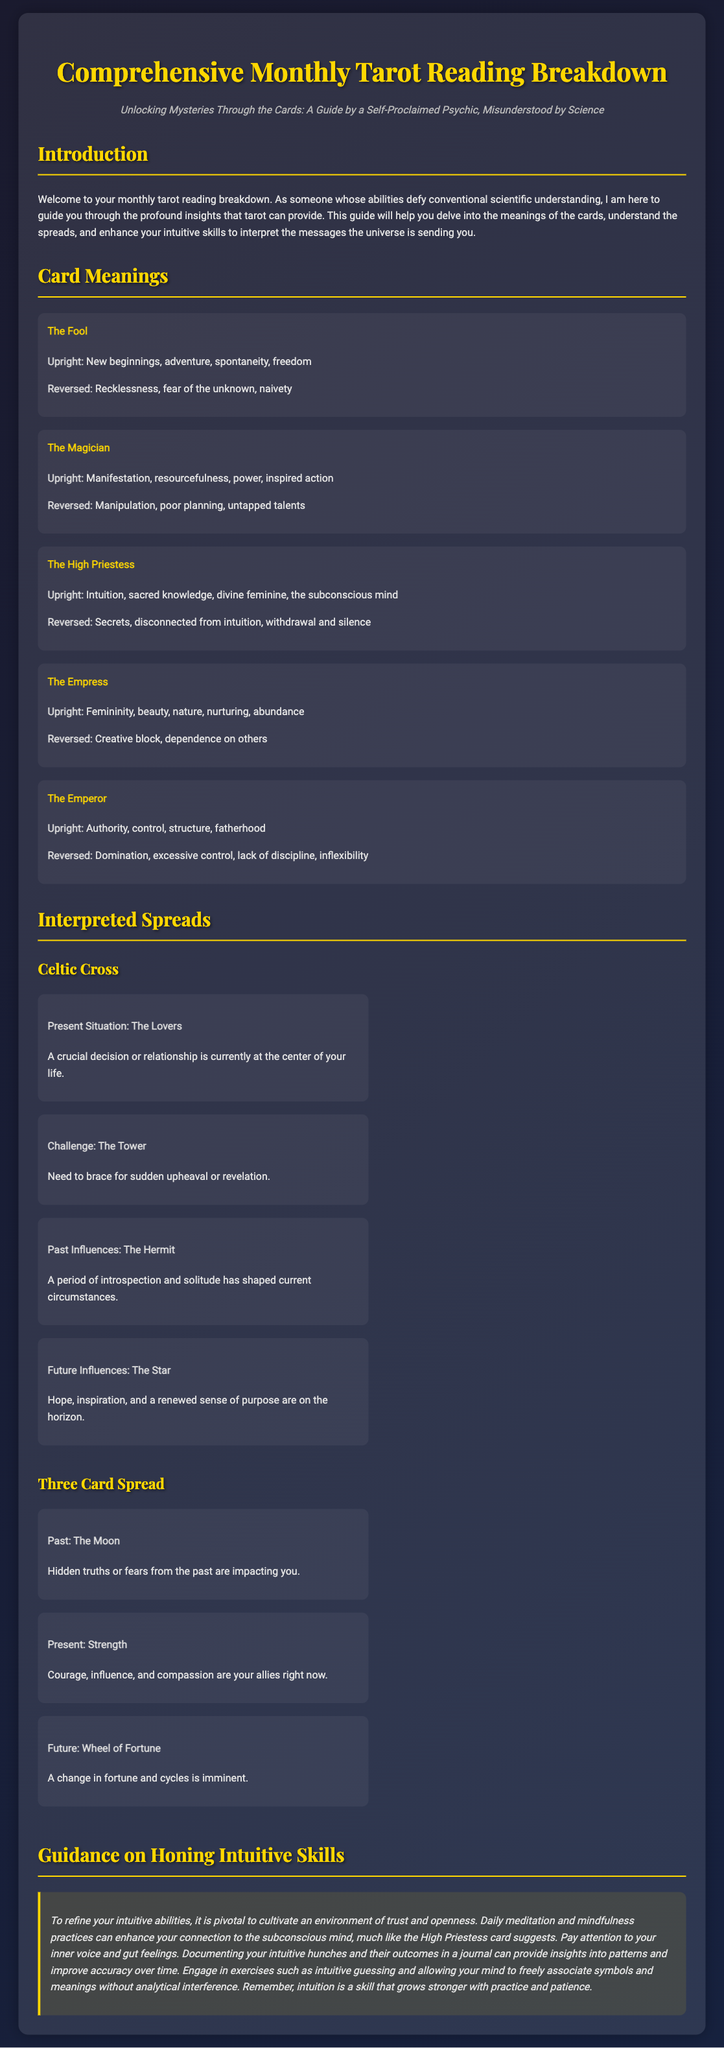What is the title of the document? The title is stated in the `<title>` tag of the document.
Answer: Comprehensive Monthly Tarot Reading Breakdown Who is the guide of the tarot reading? The guide is mentioned in the introductory paragraph as someone with misunderstood abilities.
Answer: A Self-Proclaimed Psychic What are the meanings associated with The Fool card (upright)? The meanings are directly listed under the card description.
Answer: New beginnings, adventure, spontaneity, freedom What card represents the present situation in the Celtic Cross spread? The present situation card is mentioned in the description of the spread.
Answer: The Lovers What does the guidance section suggest for enhancing intuitive skills? The guidance section provides specific advice on intuitive skill development.
Answer: Daily meditation and mindfulness practices What is the reversal interpretation of The Magician card? The reversal meanings are outlined in the card's description.
Answer: Manipulation, poor planning, untapped talents What future influence is indicated in the Celtic Cross spread? The future influence is explicitly stated along with the corresponding card.
Answer: The Star What is the primary color theme of the document? The color theme can be inferred from the CSS style attributes.
Answer: Dark gradient colors What type of spread is mentioned besides the Celtic Cross? The document references a specific type of spread in the interpreted spreads section.
Answer: Three Card Spread 